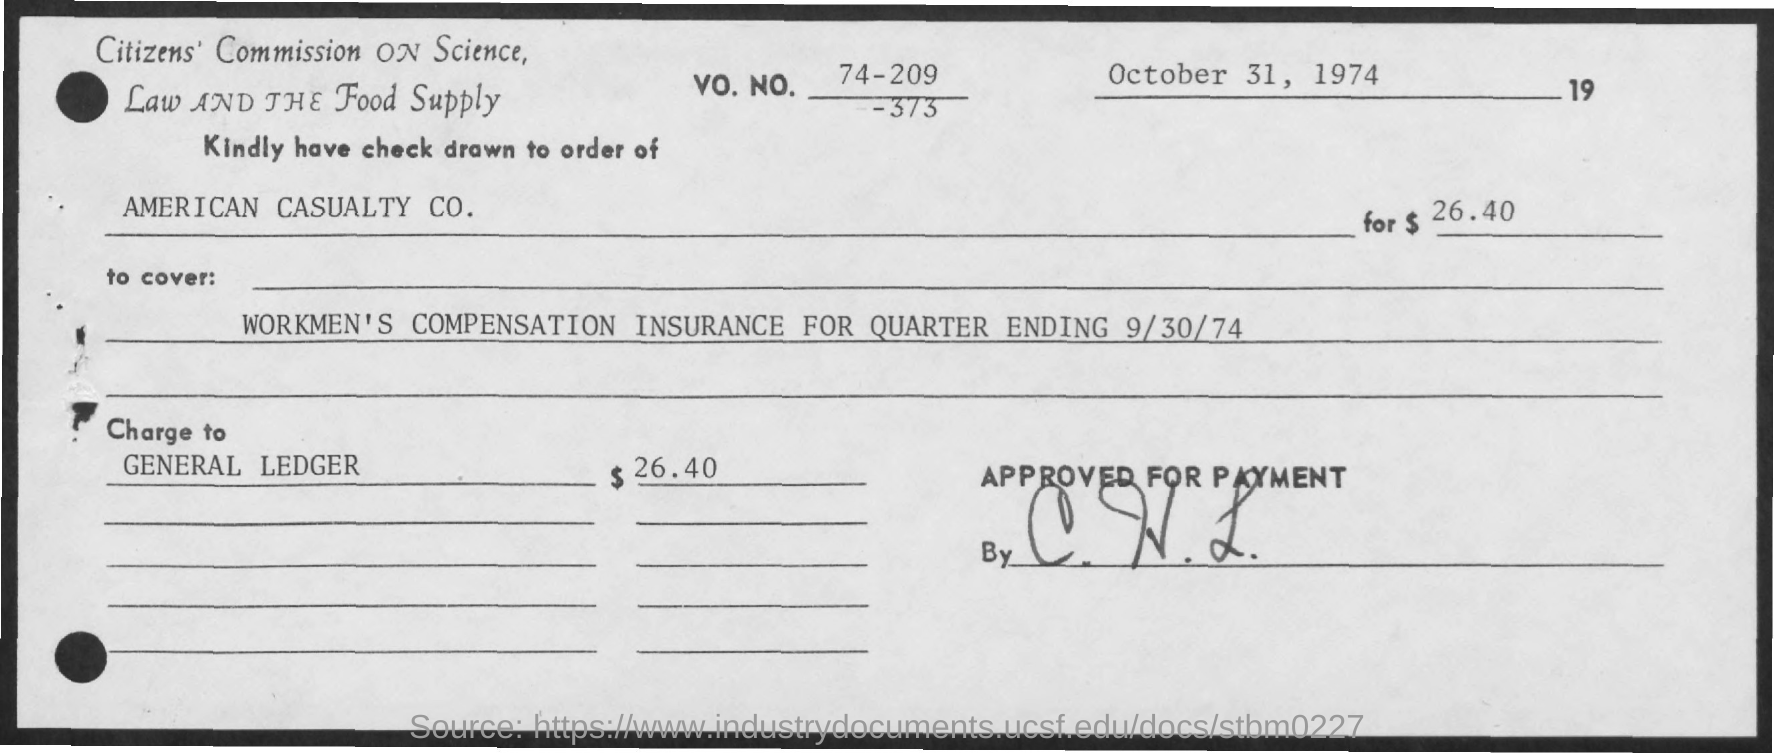Mention a couple of crucial points in this snapshot. The amount mentioned is $26.40. 